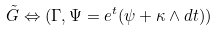Convert formula to latex. <formula><loc_0><loc_0><loc_500><loc_500>\tilde { G } \Leftrightarrow ( \Gamma , \Psi = e ^ { t } ( \psi + \kappa \wedge d t ) )</formula> 